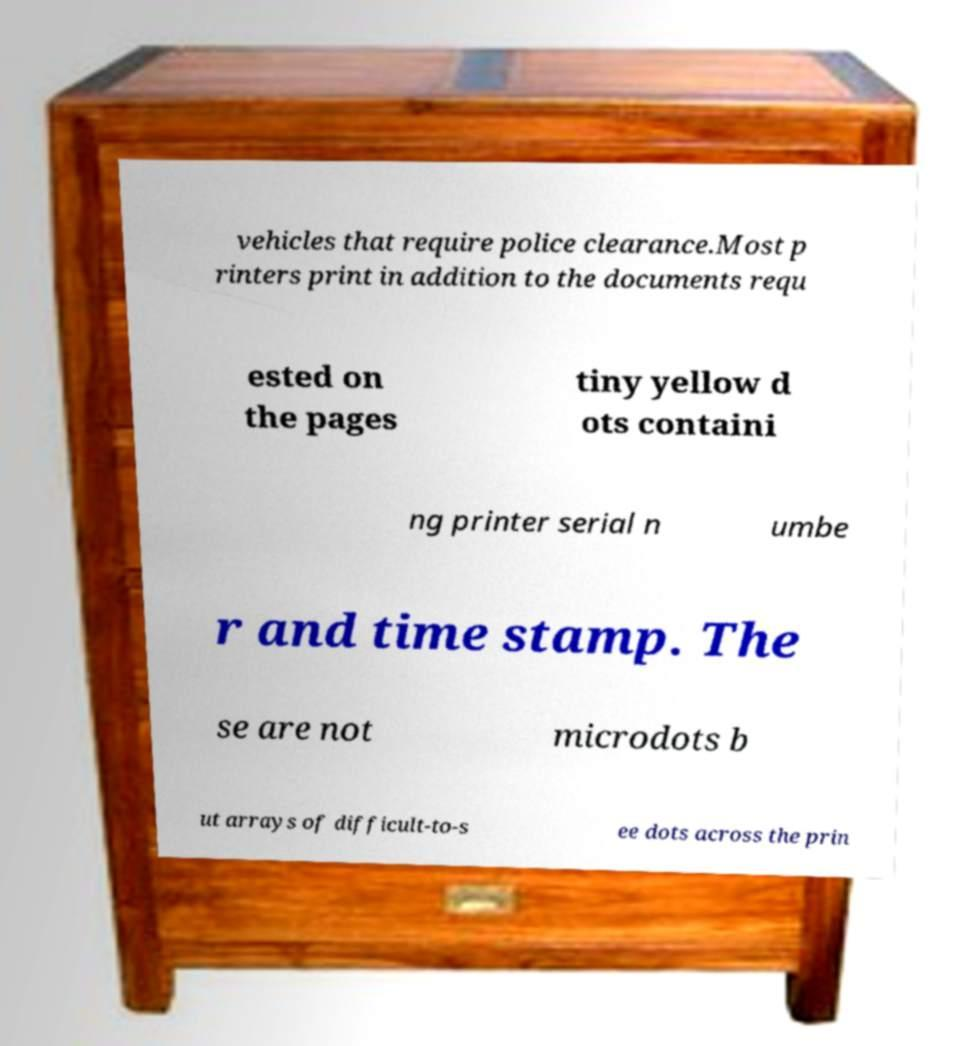What messages or text are displayed in this image? I need them in a readable, typed format. vehicles that require police clearance.Most p rinters print in addition to the documents requ ested on the pages tiny yellow d ots containi ng printer serial n umbe r and time stamp. The se are not microdots b ut arrays of difficult-to-s ee dots across the prin 